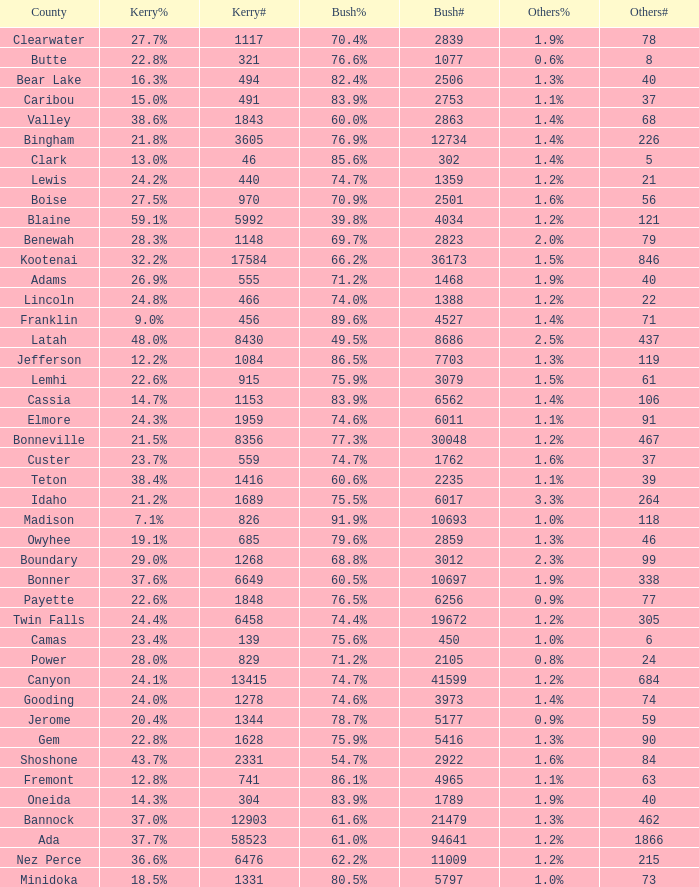What percentage of the people in Bonneville voted for Bush? 77.3%. 